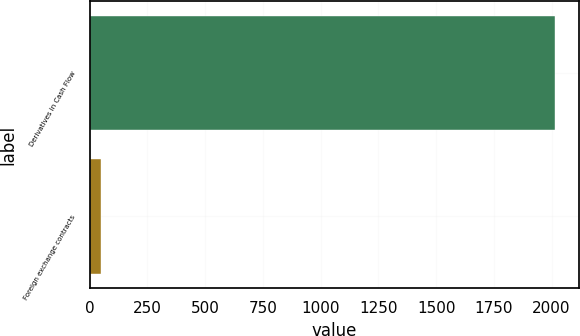<chart> <loc_0><loc_0><loc_500><loc_500><bar_chart><fcel>Derivatives in Cash Flow<fcel>Foreign exchange contracts<nl><fcel>2016<fcel>48<nl></chart> 